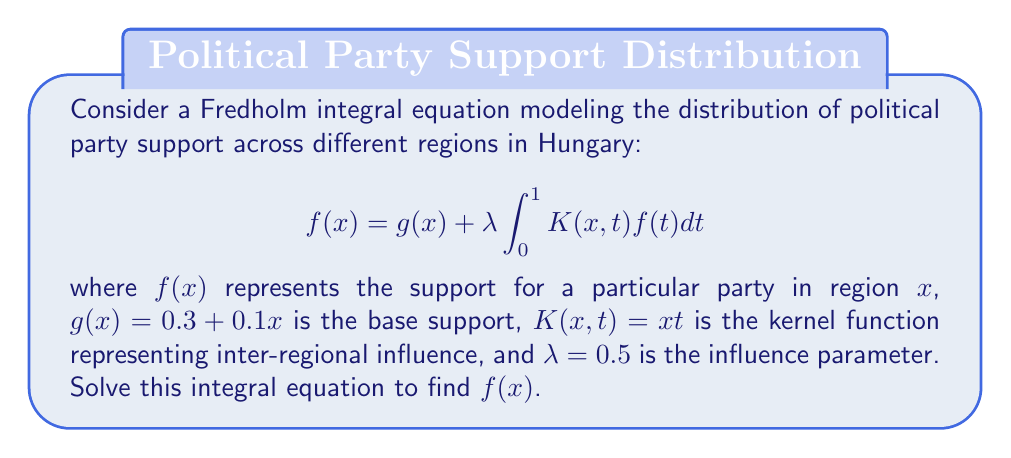What is the answer to this math problem? To solve this Fredholm integral equation, we'll follow these steps:

1) First, we assume a solution of the form $f(x) = ax + b$, where $a$ and $b$ are constants to be determined.

2) Substitute this into the right side of the equation:

   $$g(x) + \lambda \int_0^1 K(x,t)f(t)dt = (0.3 + 0.1x) + 0.5 \int_0^1 xt(at + b)dt$$

3) Evaluate the integral:

   $$(0.3 + 0.1x) + 0.5x \int_0^1 (at^2 + bt)dt$$
   $$(0.3 + 0.1x) + 0.5x \left[\frac{at^3}{3} + \frac{bt^2}{2}\right]_0^1$$
   $$(0.3 + 0.1x) + 0.5x \left(\frac{a}{3} + \frac{b}{2}\right)$$

4) This should equal our assumed solution $f(x) = ax + b$:

   $$ax + b = 0.3 + 0.1x + 0.5x \left(\frac{a}{3} + \frac{b}{2}\right)$$

5) Equate coefficients of $x$ and constant terms:

   For $x$: $a = 0.1 + 0.5 \left(\frac{a}{3} + \frac{b}{2}\right)$
   For constant: $b = 0.3$

6) From the constant term, we know $b = 0.3$. Substitute this into the equation for $a$:

   $a = 0.1 + 0.5 \left(\frac{a}{3} + \frac{0.3}{2}\right)$
   $a = 0.1 + \frac{a}{6} + 0.075$
   $\frac{5a}{6} = 0.175$
   $a = 0.21$

7) Therefore, the solution is $f(x) = 0.21x + 0.3$.
Answer: $f(x) = 0.21x + 0.3$ 